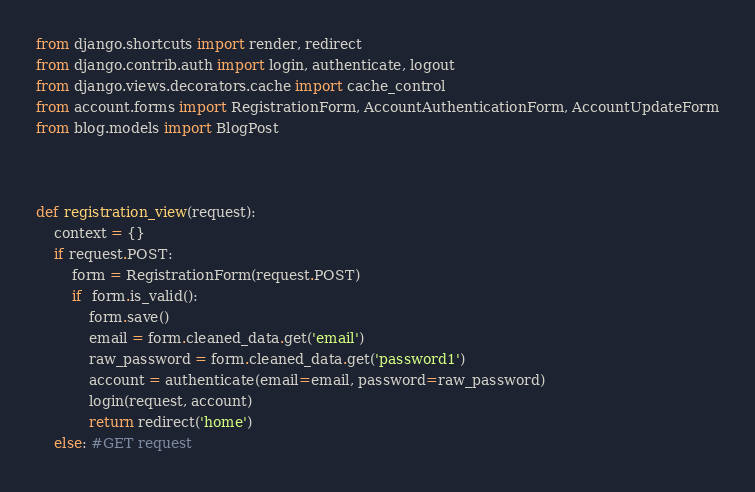<code> <loc_0><loc_0><loc_500><loc_500><_Python_>from django.shortcuts import render, redirect
from django.contrib.auth import login, authenticate, logout
from django.views.decorators.cache import cache_control
from account.forms import RegistrationForm, AccountAuthenticationForm, AccountUpdateForm
from blog.models import BlogPost



def registration_view(request):
	context = {}
	if request.POST:
		form = RegistrationForm(request.POST)
		if  form.is_valid():
			form.save()
			email = form.cleaned_data.get('email')
			raw_password = form.cleaned_data.get('password1')
			account = authenticate(email=email, password=raw_password)
			login(request, account)
			return redirect('home')
	else: #GET request</code> 